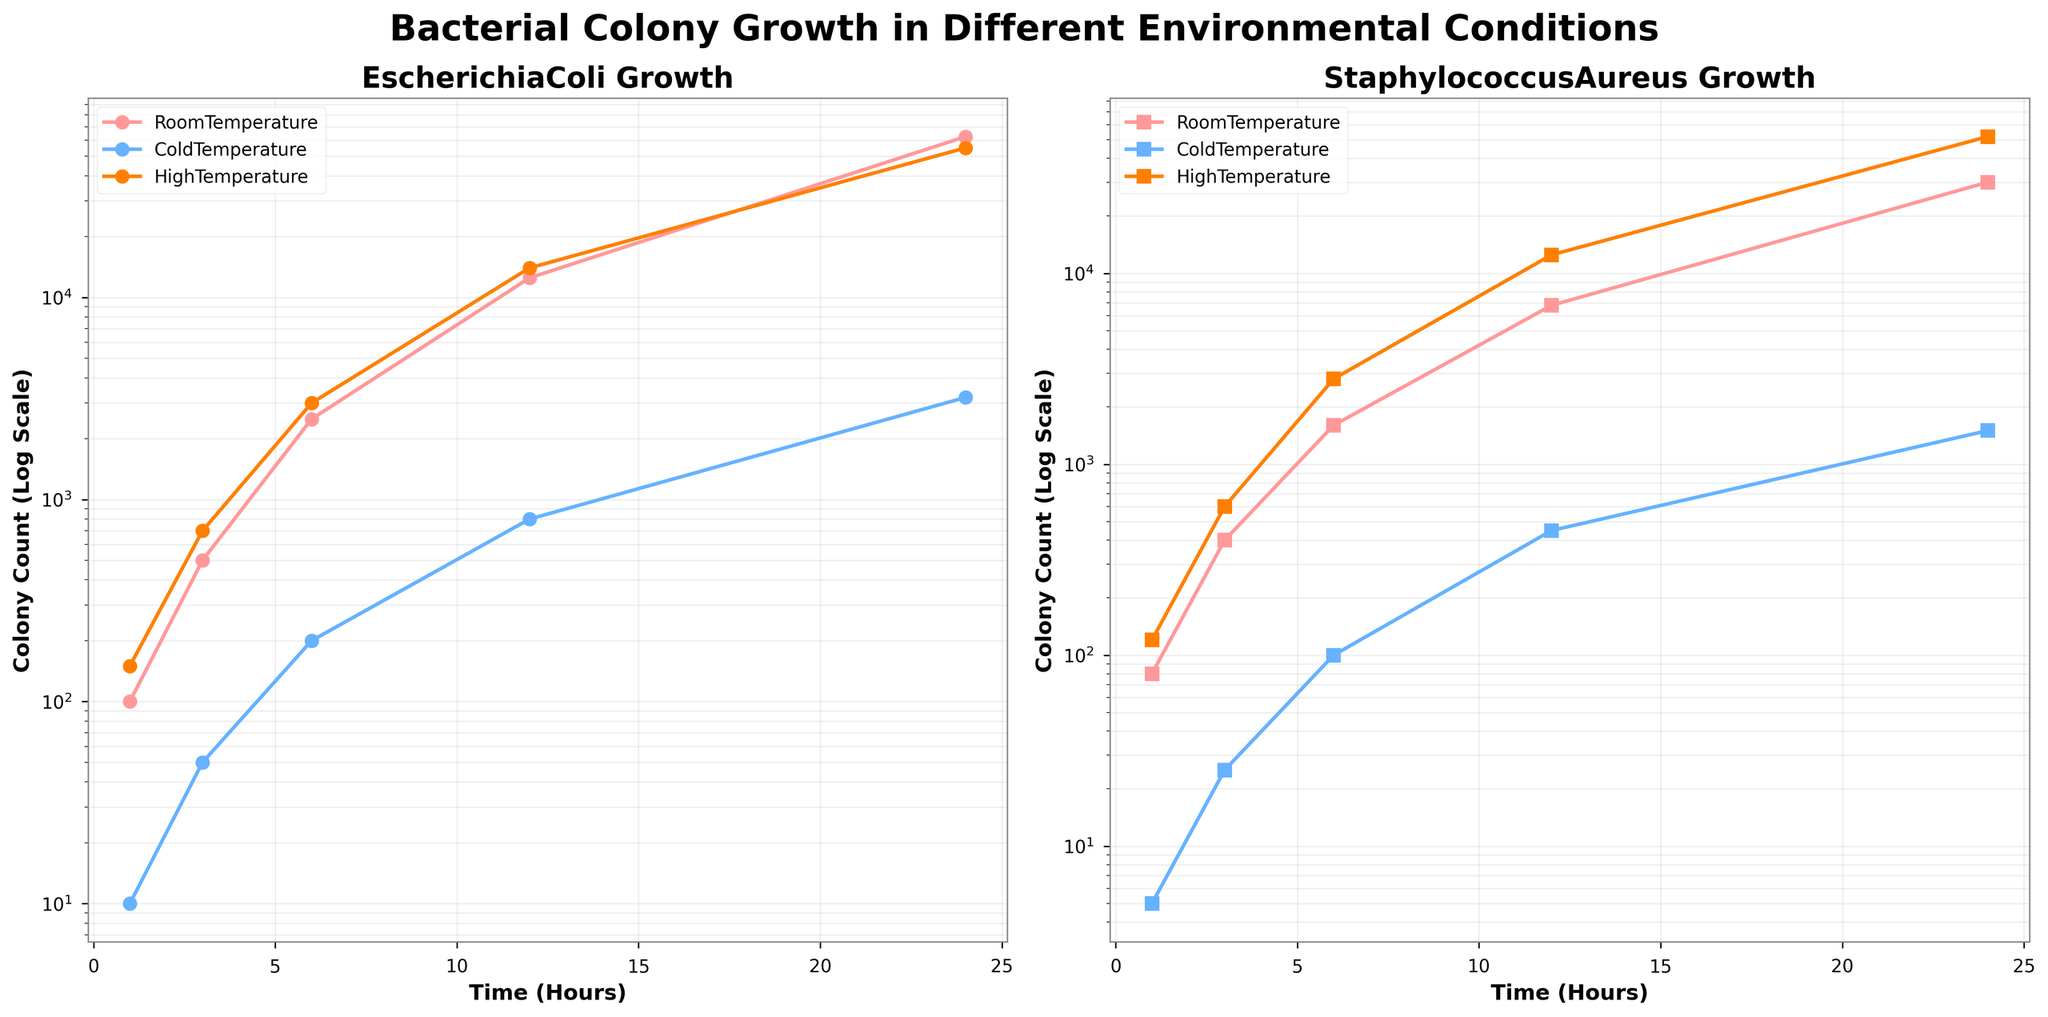What's the title of the figure? The title is found at the top center of the figure. It gives an overview of what the figure is about. The title of the figure is "Bacterial Colony Growth in Different Environmental Conditions."
Answer: Bacterial Colony Growth in Different Environmental Conditions Which environmental condition corresponds to the blue lines in the subplots? The color blue represents 'ColdTemperature' as indicated by the legend in both subplots.
Answer: ColdTemperature What is the y-axis scale used in the plots? The y-axis uses a logarithmic scale, as indicated by the label "Colony Count (Log Scale)" and the tick marks showing exponential increments.
Answer: Logarithmic Which bacterial colony has a higher count at 24 hours under room temperature: Escherichia coli or Staphylococcus aureus? To find this, compare the data points for 'RoomTemperature' for both bacterial colonies at the 24-hour mark. Escherichia coli has 62500, and Staphylococcus aureus has 30000.
Answer: Escherichia coli How does the growth rate of Escherichia coli at high temperature compare to that at cold temperature? This involves comparing the slopes of the lines for 'HighTemperature' and 'ColdTemperature' for Escherichia coli in the left subplot. The slope for 'HighTemperature' is steeper, indicating a faster growth rate compared to 'ColdTemperature'.
Answer: Faster at high temperature Which environmental condition produces the lowest colony count for Staphylococcus aureus at 12 hours? Compare the data points for 'ColdTemperature', 'RoomTemperature', and 'HighTemperature' for Staphylococcus aureus at the 12-hour mark. 'ColdTemperature' has the lowest count at 450.
Answer: ColdTemperature At what time does the colony count of Staphylococcus aureus under high temperature first exceed 10000? Examine the subplot for Staphylococcus aureus and identify when the line for 'HighTemperature' crosses the 10000 mark on the y-axis. This occurs between 6 and 12 hours.
Answer: 12 hours Compare the initial (1-hour) colony counts of Escherichia coli under all three environmental conditions. Which is the highest? The y-coordinates of the first data points for 'RoomTemperature', 'ColdTemperature', and 'HighTemperature' for Escherichia coli are 100, 10, and 150 respectively. 'HighTemperature' is the highest.
Answer: HighTemperature What is the ratio of the colony count at 24 hours to the colony count at 6 hours for Escherichia coli under high temperature? Compute this by dividing the colony count at 24 hours (55000) by the count at 6 hours (3000). \( \frac{55000}{3000} \approx 18.3 \)
Answer: 18.3 